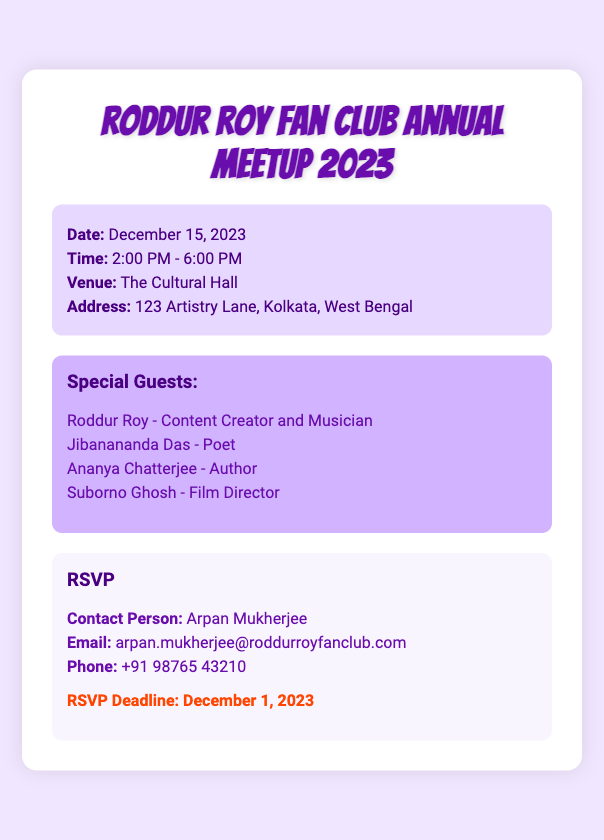what is the date of the meetup? The date of the meetup is specified in the event details section of the document.
Answer: December 15, 2023 what are the start and end times of the event? The start time and end time are provided in the event details section.
Answer: 2:00 PM - 6:00 PM where is the venue location? The venue location is included in the event details section of the RSVP card.
Answer: The Cultural Hall who is the contact person for RSVP? The contact person for RSVP is mentioned in the contact info section of the document.
Answer: Arpan Mukherjee what is the RSVP deadline? The RSVP deadline is specified in the deadline section of the RSVP card.
Answer: December 1, 2023 who is a special guest aside from Roddur Roy? The document lists several special guests, asking for one of them will relate to the guest list section.
Answer: Jibanananda Das how many special guests are mentioned in the RSVP card? The total number of special guests can be counted in the guest list section of the document.
Answer: 4 what kind of document is this? The structure and content of the document indicate its purpose and format, identified under RSVP events.
Answer: RSVP card who is the author of the RSVP document? Typically, the contact information often represents the author of the document but doesn't specify it.
Answer: Not specified 